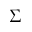Convert formula to latex. <formula><loc_0><loc_0><loc_500><loc_500>\Sigma</formula> 